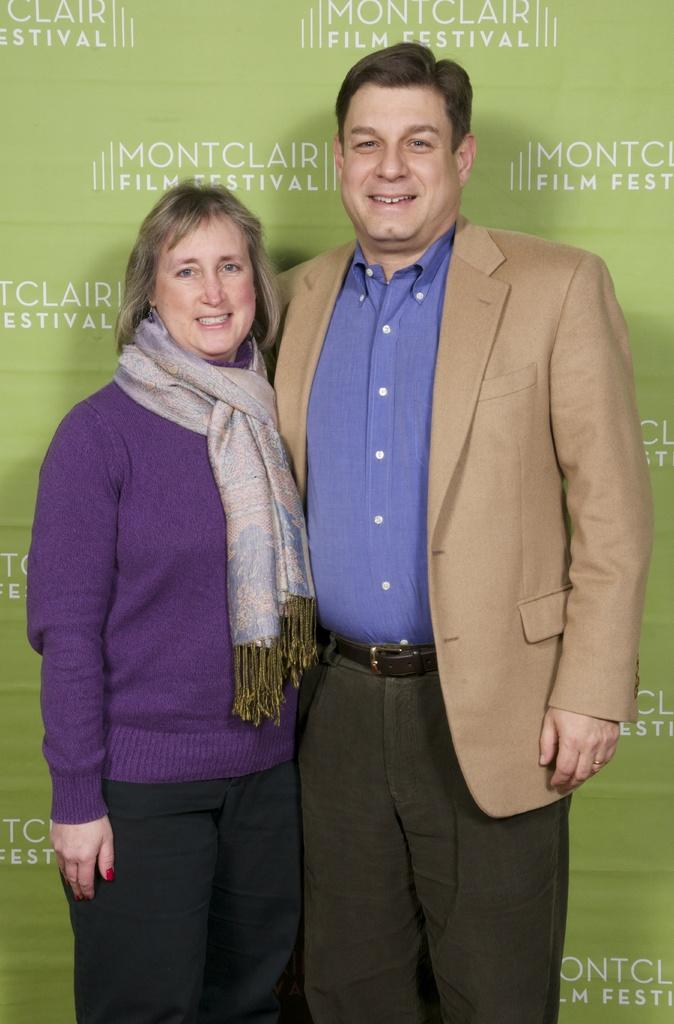What is the man in the image wearing? The man is wearing a suit, shirt, and trousers. What is the woman in the image wearing? The woman is wearing a scarf, t-shirt, and trousers. What can be seen in the background of the image? There is a banner in the background of the image. What type of haircut does the insect have in the image? There is no insect present in the image, so it is not possible to determine the type of haircut it might have. What is the man holding in the image? The facts provided do not mention any objects being held by the man, so it cannot be determined what he might be holding. 